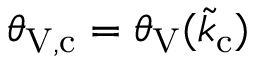Convert formula to latex. <formula><loc_0><loc_0><loc_500><loc_500>\theta _ { V , c } = \theta _ { V } ( \tilde { k } _ { c } )</formula> 